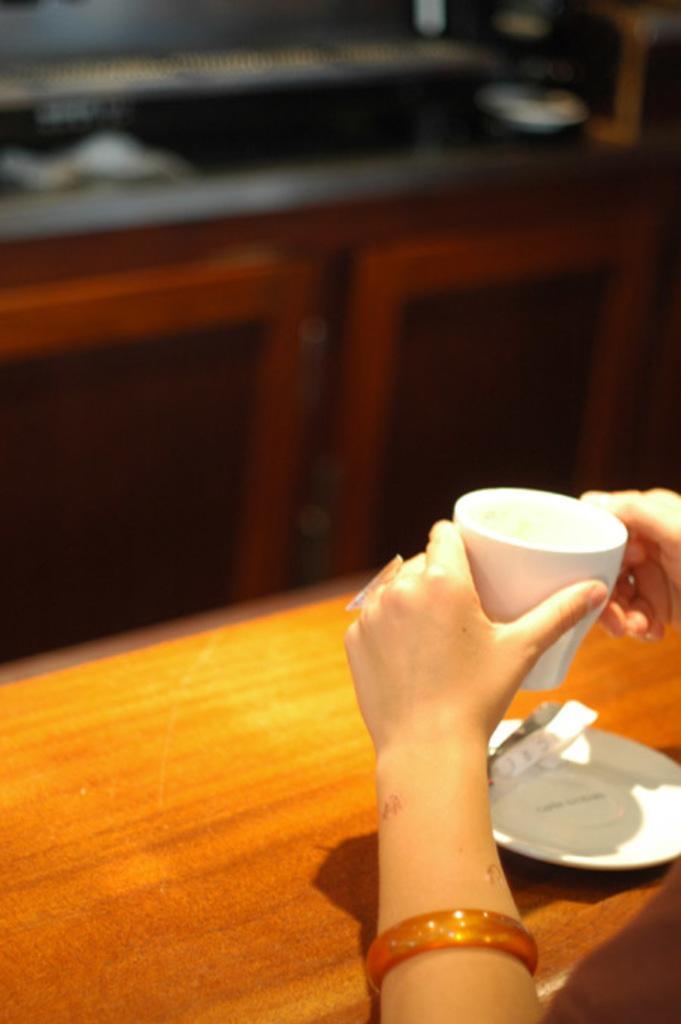In one or two sentences, can you explain what this image depicts? In the image we can see human hands holding tea cup. Here we can see a bangle and finger ring. We can even see saucer, wooden surface and the background is blurred. 